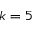<formula> <loc_0><loc_0><loc_500><loc_500>k = 5</formula> 